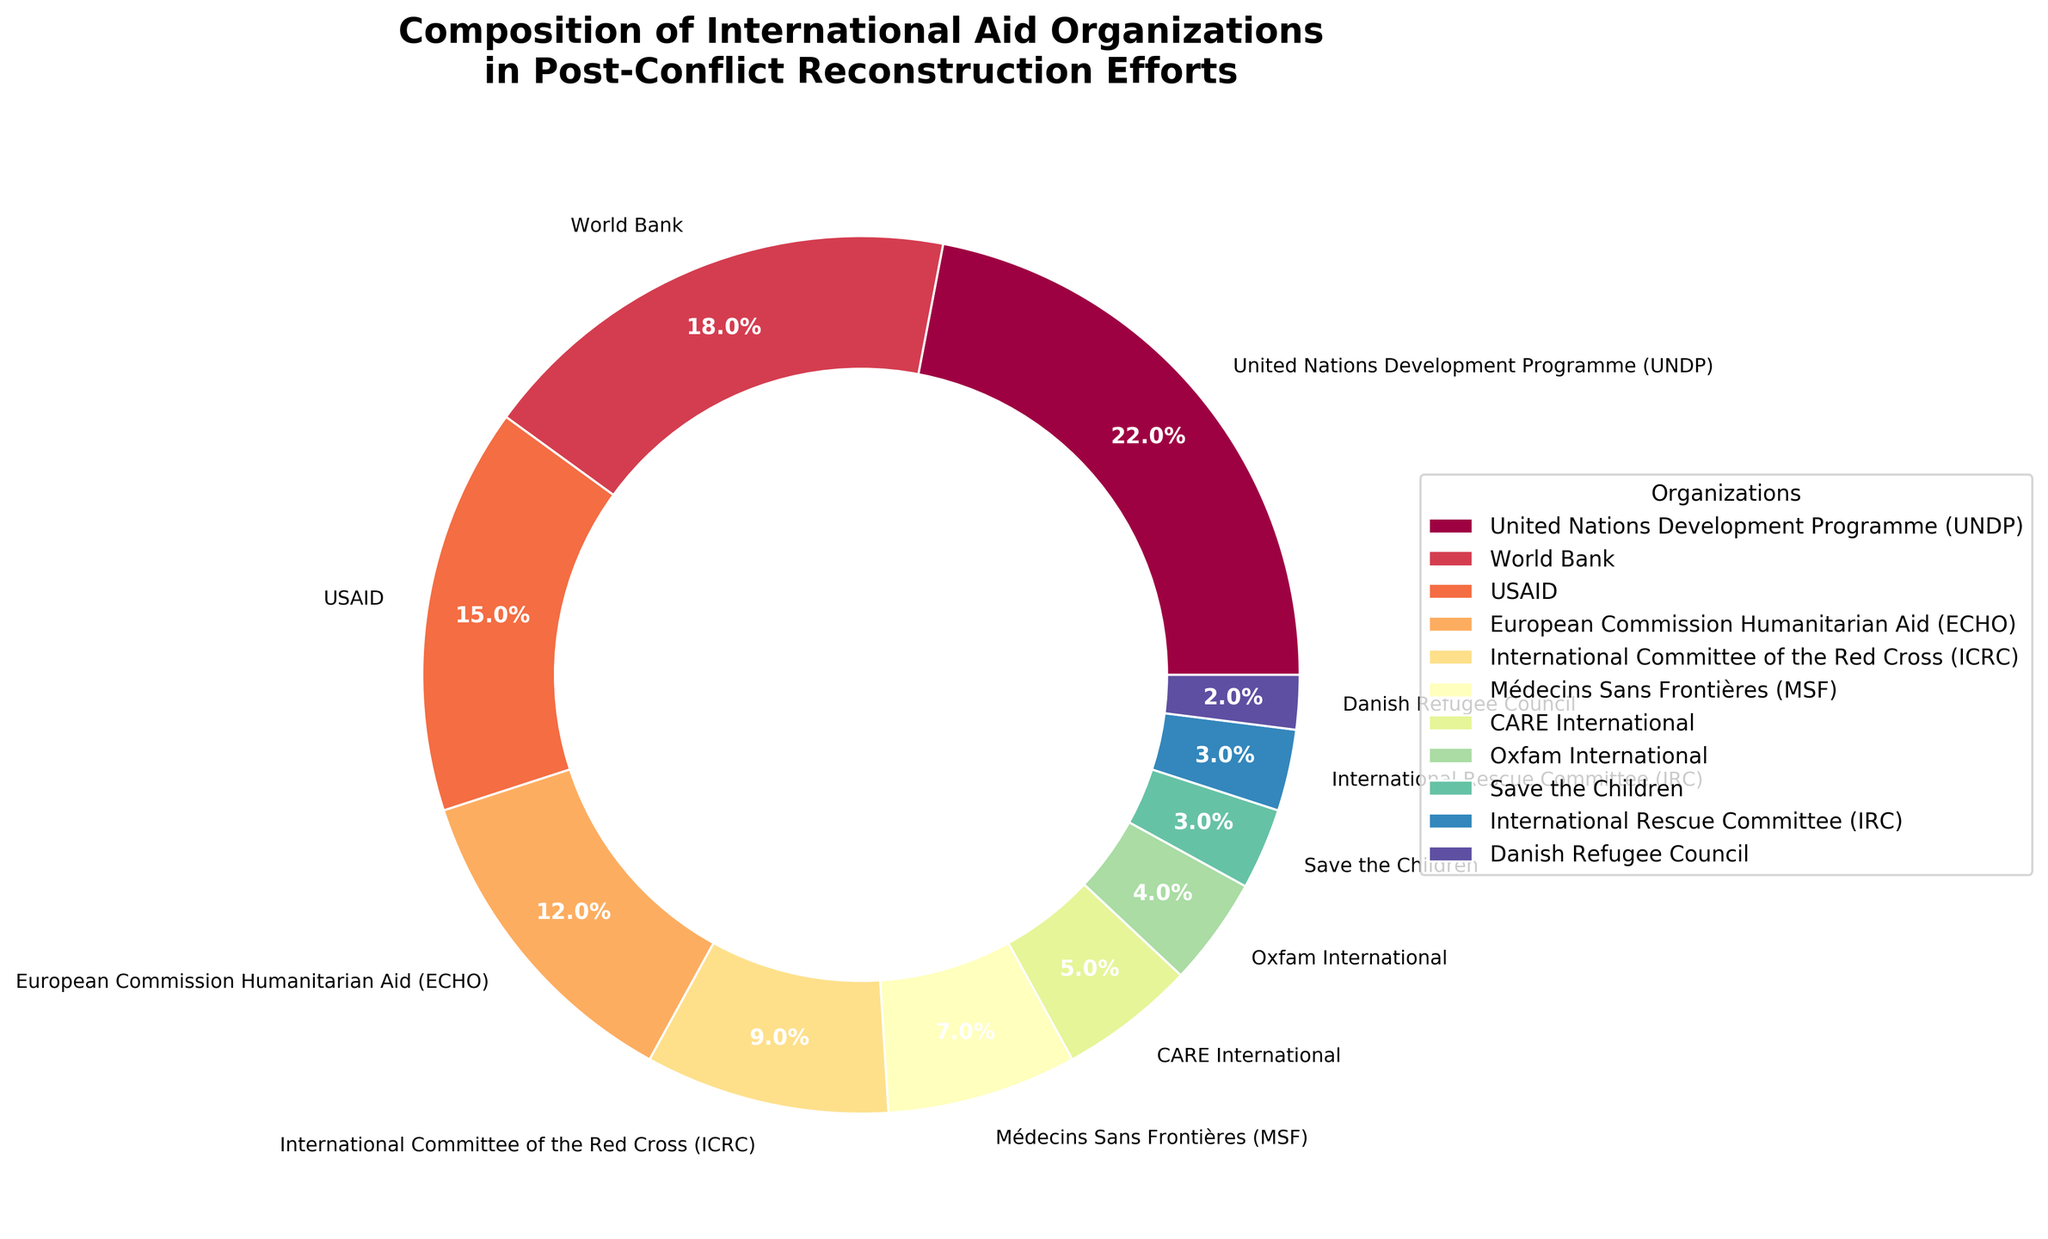What is the percentage of international aid organizations involved in reconstruction efforts represented by the United Nations Development Programme (UNDP) and the World Bank combined? To find the combined percentage, add the individual percentages of UNDP (22%) and World Bank (18%). So, 22% + 18% = 40%.
Answer: 40% Which organization has the highest percentage involvement, and what is this percentage? The organization with the highest percentage involvement is the United Nations Development Programme (UNDP) with 22% as shown in the largest section of the pie chart.
Answer: United Nations Development Programme (UNDP), 22% How much greater is the percentage involvement of USAID compared to Médecins Sans Frontières (MSF)? Subtract the percentage of MSF (7%) from the percentage of USAID (15%). So, 15% - 7% = 8%.
Answer: 8% Which organization has less involvement than both CARE International and International Committee of the Red Cross (ICRC)? The organizations with less involvement than CARE International (5%) and ICRC (9%) are Oxfam International (4%), Save the Children (3%), International Rescue Committee (3%), and Danish Refugee Council (2%).
Answer: Oxfam International, Save the Children, International Rescue Committee, Danish Refugee Council Rank the organizations from highest to lowest percentage involvement. The order can be found by comparing the size of each pie slice. The rank is: United Nations Development Programme (22%), World Bank (18%), USAID (15%), European Commission Humanitarian Aid (12%), International Committee of the Red Cross (9%), Médecins Sans Frontières (7%), CARE International (5%), Oxfam International (4%), Save the Children (3%), International Rescue Committee (3%), Danish Refugee Council (2%).
Answer: UNDP > World Bank > USAID > ECHO > ICRC > MSF > CARE > Oxfam > Save the Children > IRC > Danish Refugee Council What is the average percentage involvement of the top three organizations? Add the percentages of the top three organizations: UNDP (22%), World Bank (18%), USAID (15%), and divide by 3. So, (22% + 18% + 15%) / 3 = 55% / 3 = 18.33%.
Answer: 18.33% Are there more organizations with a percentage involvement greater than or equal to 10% or less than 10%? Count organizations greater than or equal to 10%: UNDP (22%), World Bank (18%), USAID (15%), and ECHO (12%) - that's 4 organizations. Count organizations less than 10%: ICRC (9%), MSF (7%), CARE International (5%), Oxfam International (4%), Save the Children (3%), International Rescue Committee (3%), Danish Refugee Council (2%) - that's 7 organizations. There are more organizations with less than 10%.
Answer: More with less than 10% Identify the organization with the smallest slice on the pie chart and specify its percentage involvement. The smallest slice on the pie chart corresponds to the Danish Refugee Council with a 2% involvement.
Answer: Danish Refugee Council, 2% How does the percentage of the European Commission Humanitarian Aid (ECHO) compare to the combined percentage of Oxfam International and Save the Children? The percentage of ECHO is 12%. The combined percentage of Oxfam International (4%) and Save the Children (3%) is 4% + 3% = 7%. Therefore, ECHO's percentage is greater.
Answer: ECHO's percentage is greater than the combined percentage of Oxfam International and Save the Children What is the total percentage of all organizations involved? The sum of all the presented percentages (22 + 18 + 15 + 12 + 9 + 7 + 5 + 4 + 3 + 3 + 2) equals 100%.
Answer: 100% 